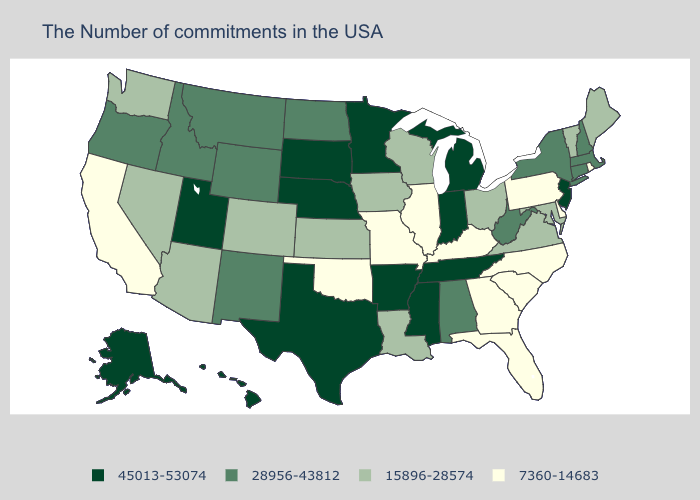Name the states that have a value in the range 45013-53074?
Answer briefly. New Jersey, Michigan, Indiana, Tennessee, Mississippi, Arkansas, Minnesota, Nebraska, Texas, South Dakota, Utah, Alaska, Hawaii. What is the value of Minnesota?
Give a very brief answer. 45013-53074. What is the lowest value in the MidWest?
Concise answer only. 7360-14683. Name the states that have a value in the range 15896-28574?
Be succinct. Maine, Vermont, Maryland, Virginia, Ohio, Wisconsin, Louisiana, Iowa, Kansas, Colorado, Arizona, Nevada, Washington. Among the states that border Tennessee , does Arkansas have the lowest value?
Answer briefly. No. What is the value of South Dakota?
Give a very brief answer. 45013-53074. Which states have the lowest value in the USA?
Be succinct. Rhode Island, Delaware, Pennsylvania, North Carolina, South Carolina, Florida, Georgia, Kentucky, Illinois, Missouri, Oklahoma, California. Does Montana have the highest value in the West?
Short answer required. No. Name the states that have a value in the range 28956-43812?
Write a very short answer. Massachusetts, New Hampshire, Connecticut, New York, West Virginia, Alabama, North Dakota, Wyoming, New Mexico, Montana, Idaho, Oregon. What is the value of New Hampshire?
Concise answer only. 28956-43812. Which states hav the highest value in the South?
Keep it brief. Tennessee, Mississippi, Arkansas, Texas. What is the lowest value in the Northeast?
Keep it brief. 7360-14683. Does Nebraska have the same value as Alaska?
Short answer required. Yes. Among the states that border West Virginia , which have the lowest value?
Concise answer only. Pennsylvania, Kentucky. 